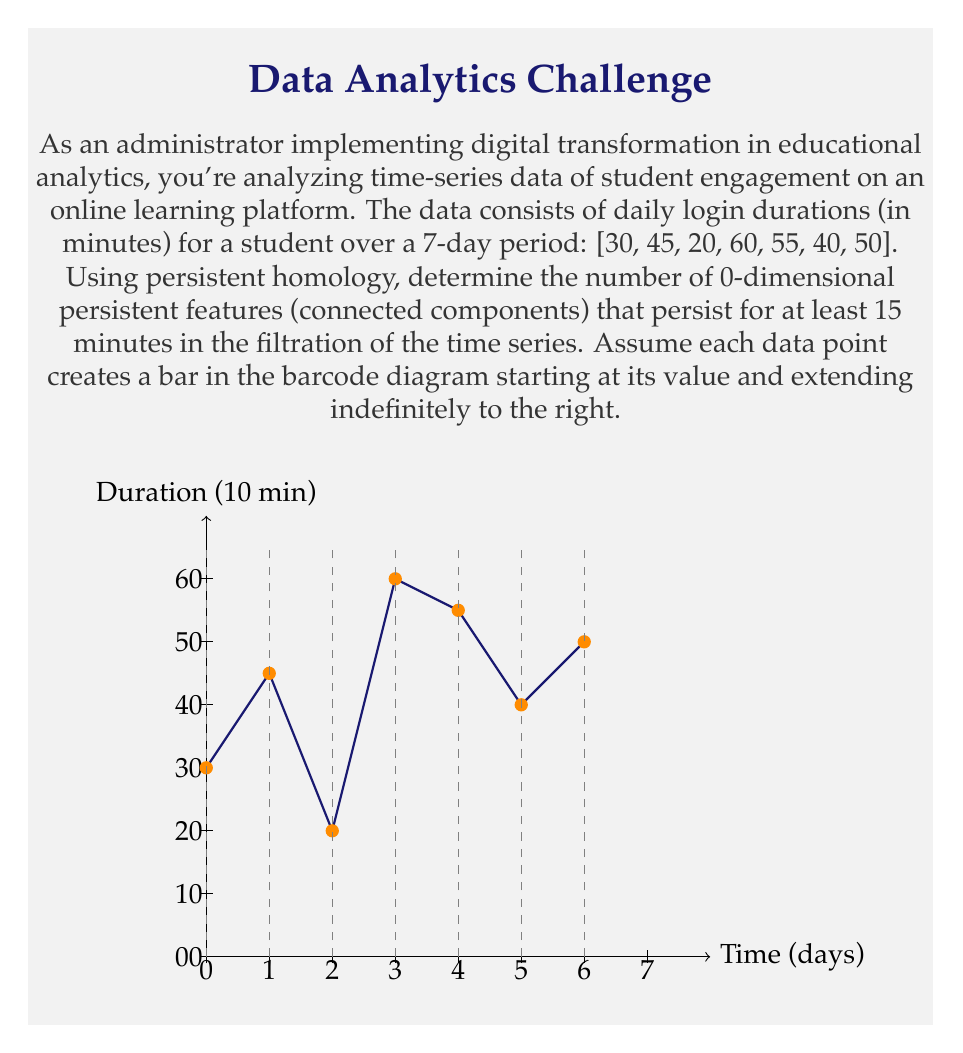Can you solve this math problem? To solve this problem using persistent homology, we'll follow these steps:

1) First, we need to understand what persistent homology means in this context:
   - Each data point creates a bar in the barcode diagram.
   - The bar starts at the value of the data point and extends indefinitely to the right.
   - 0-dimensional features (connected components) persist until they merge with a higher value.

2) Let's create the barcode diagram:
   - Day 1: 30 minutes - creates a bar starting at 30
   - Day 2: 45 minutes - creates a bar starting at 45, merges with 30
   - Day 3: 20 minutes - creates a bar starting at 20
   - Day 4: 60 minutes - creates a bar starting at 60, merges all previous
   - Day 5: 55 minutes - creates a bar starting at 55
   - Day 6: 40 minutes - creates a bar starting at 40
   - Day 7: 50 minutes - creates a bar starting at 50, merges with 40

3) Now, let's identify the persistent features:
   - The bar starting at 20 persists until it merges at 60 (persistence of 40 minutes)
   - The bar starting at 30 persists until it merges at 45 (persistence of 15 minutes)
   - The bar starting at 40 persists until it merges at 50 (persistence of 10 minutes)
   - The bars starting at 45, 55, and 60 have persistence of 0 minutes as they're immediately merged

4) Count the number of features persisting for at least 15 minutes:
   - 20 to 60: persists for 40 minutes
   - 30 to 45: persists for 15 minutes
   - All others persist for less than 15 minutes

Therefore, there are 2 0-dimensional persistent features that persist for at least 15 minutes.
Answer: 2 